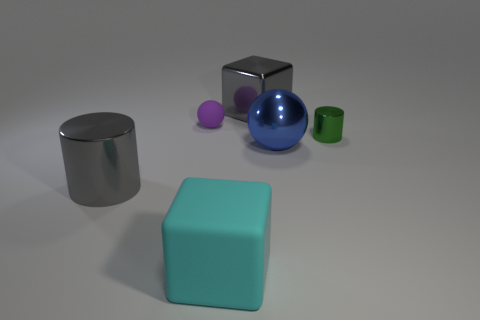Add 3 large blue spheres. How many objects exist? 9 Subtract all cubes. How many objects are left? 4 Subtract all tiny red blocks. Subtract all gray metallic objects. How many objects are left? 4 Add 4 cyan rubber things. How many cyan rubber things are left? 5 Add 1 small gray objects. How many small gray objects exist? 1 Subtract 0 brown balls. How many objects are left? 6 